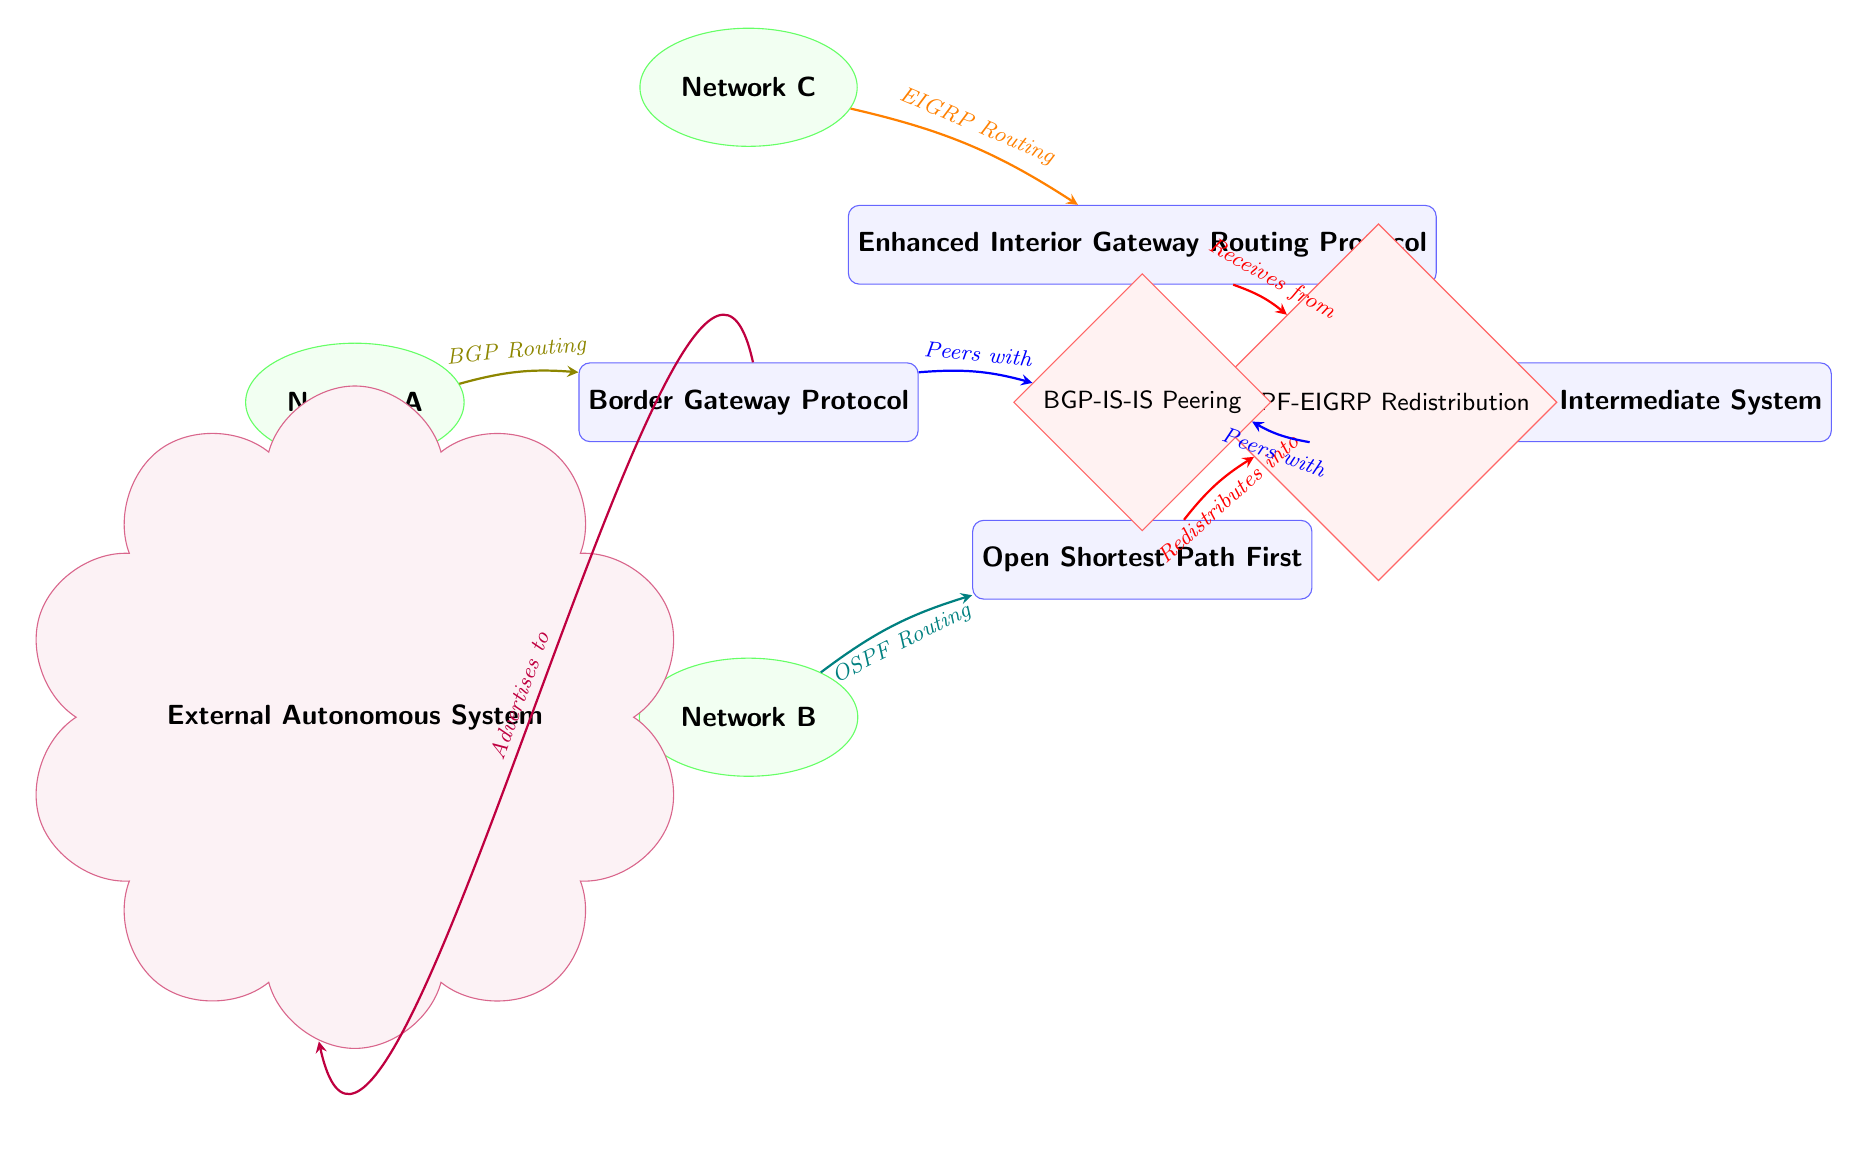What are the protocols illustrated in the diagram? The diagram shows four protocols: Border Gateway Protocol, Open Shortest Path First, Enhanced Interior Gateway Routing Protocol, and Intermediate System to Intermediate System. These are labeled clearly on the diagram.
Answer: Border Gateway Protocol, Open Shortest Path First, Enhanced Interior Gateway Routing Protocol, Intermediate System to Intermediate System Which network uses OSPF routing? In the diagram, Network B is connected to the OSPF protocol node. The arrow shows the direction from Network B labeled "OSPF Routing," indicating this relationship.
Answer: Network B How many interaction nodes are present? There are two interaction nodes in the diagram: OSPF-EIGRP Redistribution and BGP-IS-IS Peering. We can see two diamond-shaped nodes designated as interactions.
Answer: 2 What routing protocol does Network A use to communicate with external Autonomous System? Network A communicates with the external Autonomous System using the Border Gateway Protocol, as indicated by the arrow that shows "Advertises to" leading from BGP to External AS.
Answer: Border Gateway Protocol Which protocols are involved in the redistribution shown in the diagram? The redistribution interaction node labeled OSPF-EIGRP shows that OSPF sends routes to EIGRP, which is indicated by the directing arrows labeled "Redistributes into" and "Receives from". Hence, both protocols contribute to this process.
Answer: OSPF, EIGRP What is the type of interaction between BGP and IS-IS? The interaction between BGP and IS-IS is defined as "Peers with," as illustrated by the arrows leading to the BGP-IS-IS Peering node, indicating a peering relationship.
Answer: Peering Which networks are involved in the OSPF-EIGRP redistribution? The networks involved are Network B and Network C. Network B uses OSPF, which redistributes routes to Network C that uses EIGRP, as shown by the arrows leading to and from the interaction node.
Answer: Network B, Network C What is the relationship type depicted by the arrows connecting the protocol nodes to the networks? The arrows connecting the protocol nodes to the networks represent routing relationships, indicating that each network utilizes the associated protocol for routing purposes.
Answer: Routing relationships 